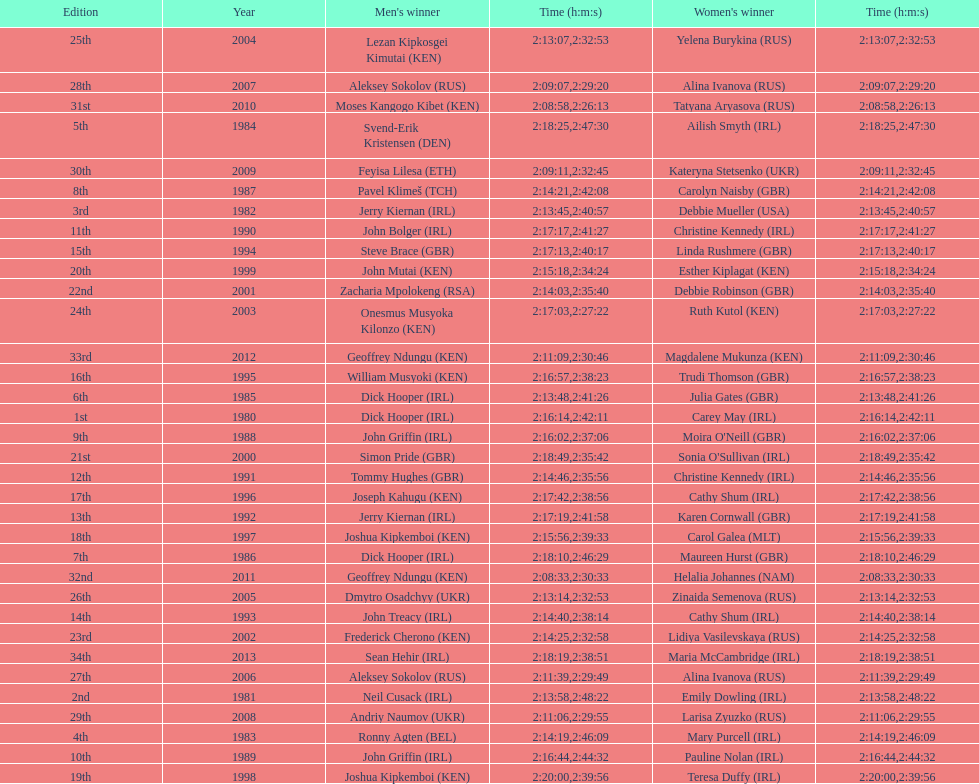Who had the most amount of time out of all the runners? Maria McCambridge (IRL). 